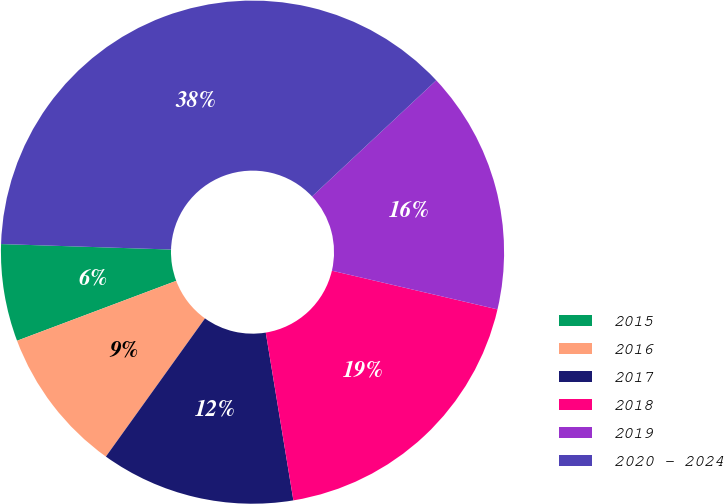Convert chart. <chart><loc_0><loc_0><loc_500><loc_500><pie_chart><fcel>2015<fcel>2016<fcel>2017<fcel>2018<fcel>2019<fcel>2020 - 2024<nl><fcel>6.24%<fcel>9.37%<fcel>12.5%<fcel>18.75%<fcel>15.62%<fcel>37.52%<nl></chart> 